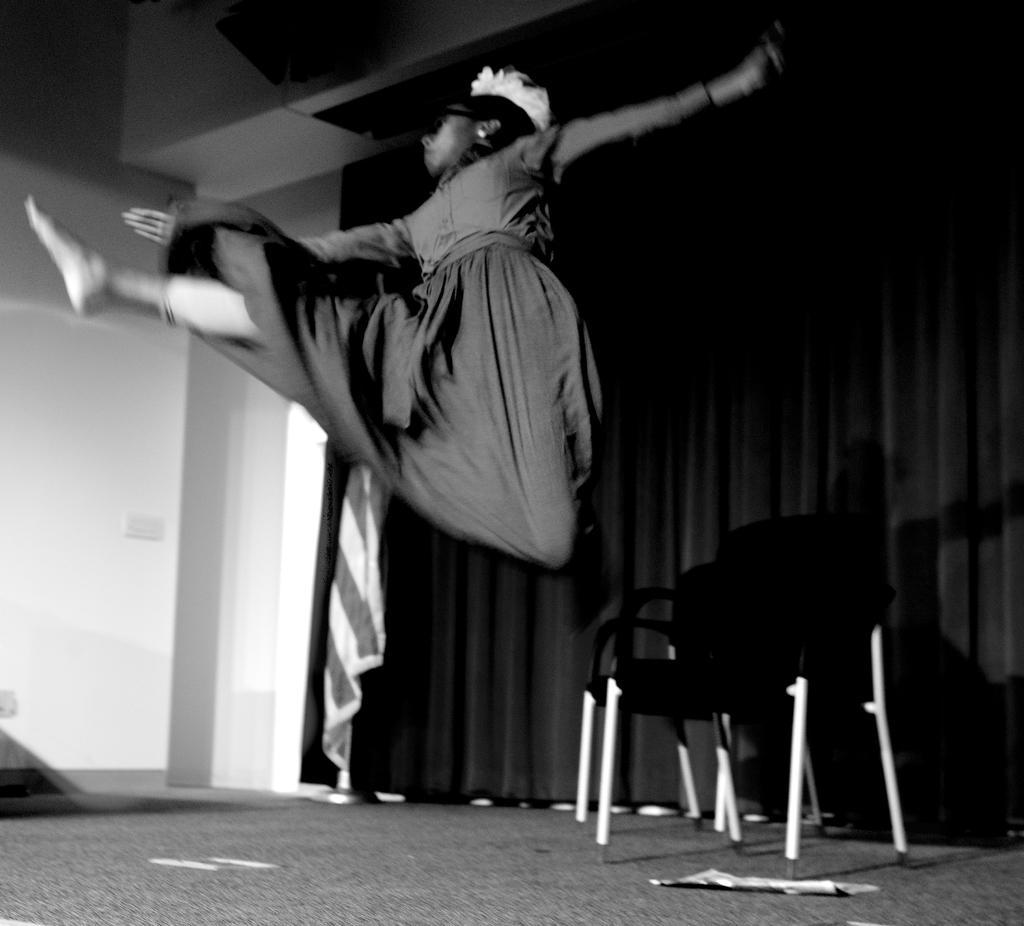Please provide a concise description of this image. This is a black and white image. In this image we can see a woman. We can also see a group of chairs and some papers on the floor, a curtain and a wall. 